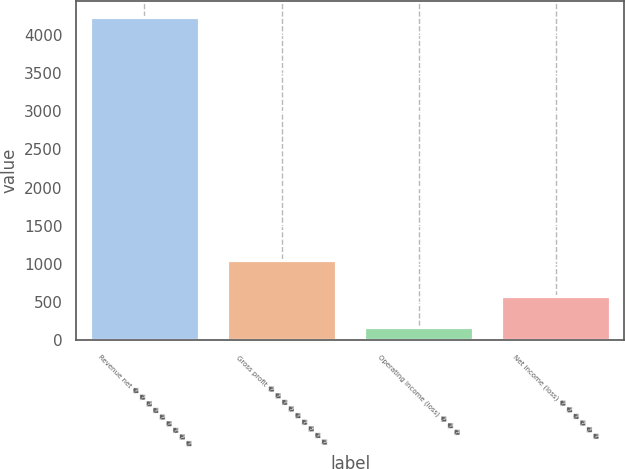Convert chart. <chart><loc_0><loc_0><loc_500><loc_500><bar_chart><fcel>Revenue net � � � � � � � � �<fcel>Gross profit � � � � � � � � �<fcel>Operating income (loss) � � �<fcel>Net income (loss) � � � � � �<nl><fcel>4233<fcel>1044<fcel>176<fcel>581.7<nl></chart> 